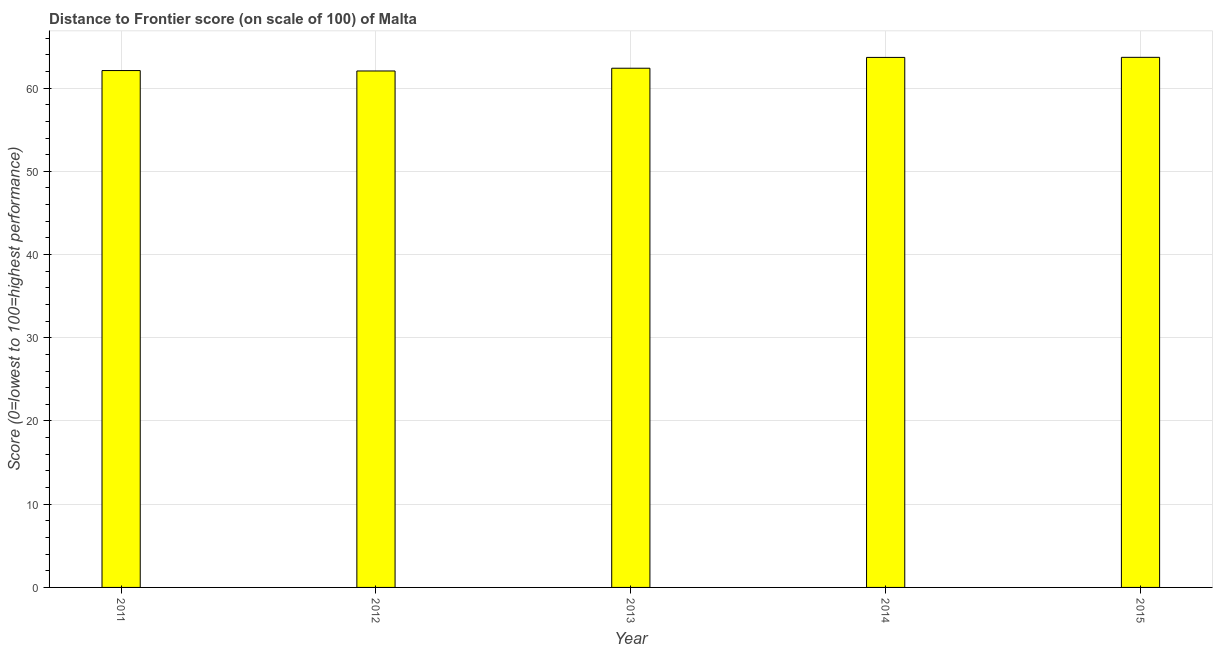Does the graph contain any zero values?
Your answer should be very brief. No. What is the title of the graph?
Offer a terse response. Distance to Frontier score (on scale of 100) of Malta. What is the label or title of the X-axis?
Provide a succinct answer. Year. What is the label or title of the Y-axis?
Your answer should be very brief. Score (0=lowest to 100=highest performance). What is the distance to frontier score in 2011?
Keep it short and to the point. 62.11. Across all years, what is the maximum distance to frontier score?
Offer a very short reply. 63.7. Across all years, what is the minimum distance to frontier score?
Your answer should be compact. 62.06. In which year was the distance to frontier score maximum?
Your response must be concise. 2015. In which year was the distance to frontier score minimum?
Offer a very short reply. 2012. What is the sum of the distance to frontier score?
Provide a short and direct response. 313.95. What is the difference between the distance to frontier score in 2011 and 2015?
Your response must be concise. -1.59. What is the average distance to frontier score per year?
Keep it short and to the point. 62.79. What is the median distance to frontier score?
Provide a short and direct response. 62.39. Do a majority of the years between 2015 and 2012 (inclusive) have distance to frontier score greater than 58 ?
Your answer should be compact. Yes. Is the distance to frontier score in 2011 less than that in 2013?
Keep it short and to the point. Yes. What is the difference between the highest and the lowest distance to frontier score?
Give a very brief answer. 1.64. In how many years, is the distance to frontier score greater than the average distance to frontier score taken over all years?
Provide a succinct answer. 2. Are all the bars in the graph horizontal?
Provide a succinct answer. No. How many years are there in the graph?
Give a very brief answer. 5. What is the Score (0=lowest to 100=highest performance) in 2011?
Give a very brief answer. 62.11. What is the Score (0=lowest to 100=highest performance) in 2012?
Provide a short and direct response. 62.06. What is the Score (0=lowest to 100=highest performance) of 2013?
Provide a succinct answer. 62.39. What is the Score (0=lowest to 100=highest performance) in 2014?
Provide a short and direct response. 63.69. What is the Score (0=lowest to 100=highest performance) of 2015?
Keep it short and to the point. 63.7. What is the difference between the Score (0=lowest to 100=highest performance) in 2011 and 2012?
Your answer should be compact. 0.05. What is the difference between the Score (0=lowest to 100=highest performance) in 2011 and 2013?
Your answer should be very brief. -0.28. What is the difference between the Score (0=lowest to 100=highest performance) in 2011 and 2014?
Provide a succinct answer. -1.58. What is the difference between the Score (0=lowest to 100=highest performance) in 2011 and 2015?
Provide a short and direct response. -1.59. What is the difference between the Score (0=lowest to 100=highest performance) in 2012 and 2013?
Your answer should be very brief. -0.33. What is the difference between the Score (0=lowest to 100=highest performance) in 2012 and 2014?
Your answer should be very brief. -1.63. What is the difference between the Score (0=lowest to 100=highest performance) in 2012 and 2015?
Give a very brief answer. -1.64. What is the difference between the Score (0=lowest to 100=highest performance) in 2013 and 2015?
Make the answer very short. -1.31. What is the difference between the Score (0=lowest to 100=highest performance) in 2014 and 2015?
Make the answer very short. -0.01. What is the ratio of the Score (0=lowest to 100=highest performance) in 2011 to that in 2014?
Provide a succinct answer. 0.97. What is the ratio of the Score (0=lowest to 100=highest performance) in 2011 to that in 2015?
Keep it short and to the point. 0.97. What is the ratio of the Score (0=lowest to 100=highest performance) in 2012 to that in 2015?
Ensure brevity in your answer.  0.97. What is the ratio of the Score (0=lowest to 100=highest performance) in 2013 to that in 2014?
Your answer should be compact. 0.98. What is the ratio of the Score (0=lowest to 100=highest performance) in 2013 to that in 2015?
Provide a short and direct response. 0.98. 